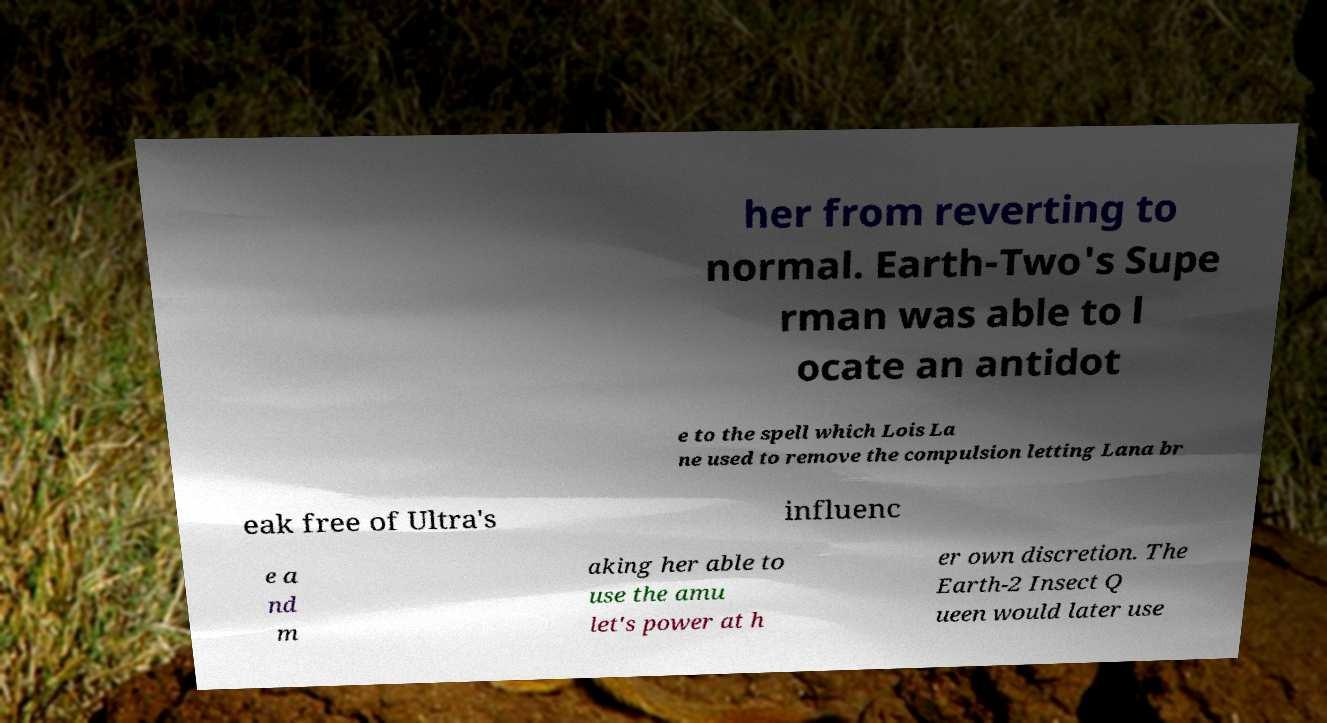Can you read and provide the text displayed in the image?This photo seems to have some interesting text. Can you extract and type it out for me? her from reverting to normal. Earth-Two's Supe rman was able to l ocate an antidot e to the spell which Lois La ne used to remove the compulsion letting Lana br eak free of Ultra's influenc e a nd m aking her able to use the amu let's power at h er own discretion. The Earth-2 Insect Q ueen would later use 